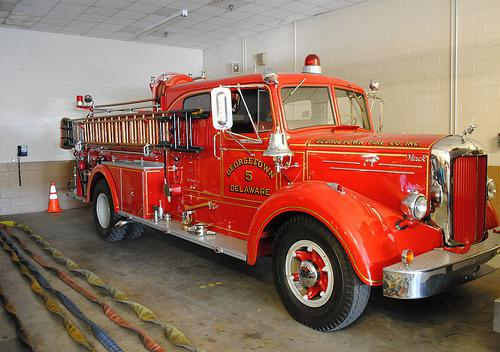Question: what is it?
Choices:
A. Fire truck.
B. A school bus.
C. A train.
D. A tow truck.
Answer with the letter. Answer: A Question: how many cones?
Choices:
A. 2.
B. 1.
C. 3.
D. 4.
Answer with the letter. Answer: B 